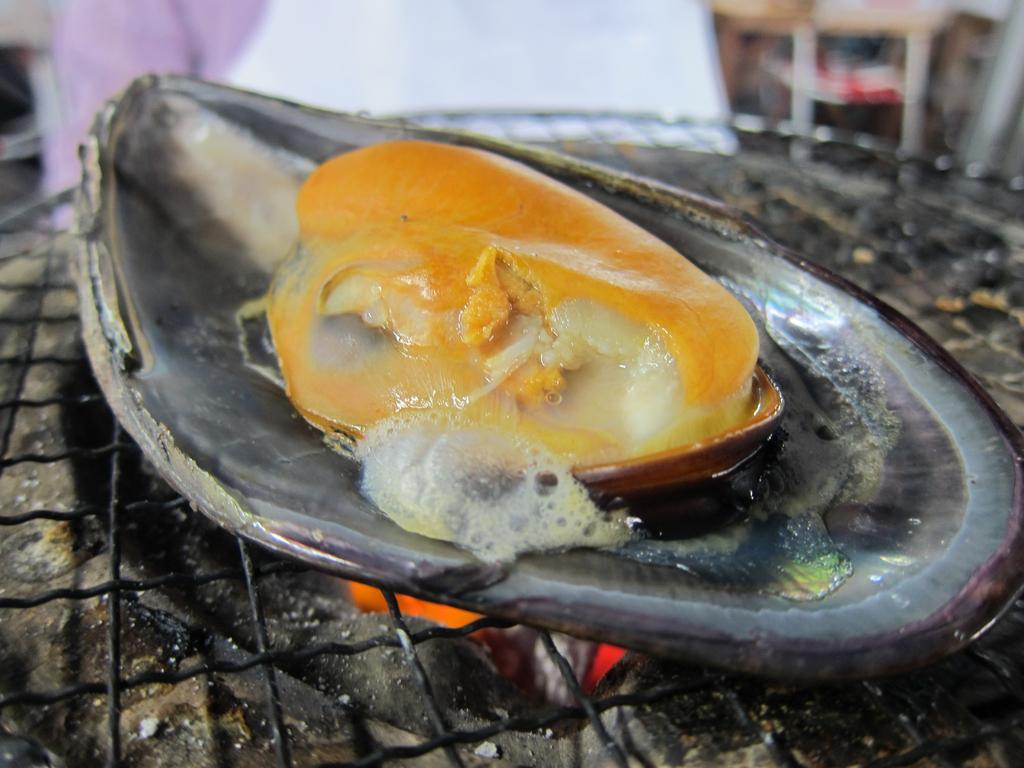What is being cooked in the image? There is a food item on the grill in the image. What stage of cooking is the food item in? The food item is in the cooking stage. Can you describe the person visible in the background of the image? Unfortunately, the provided facts do not give any information about the person in the background. What type of care does the creator of the food item need during the summer? There is no information about the creator of the food item or the season in the provided facts, so we cannot answer this question. 